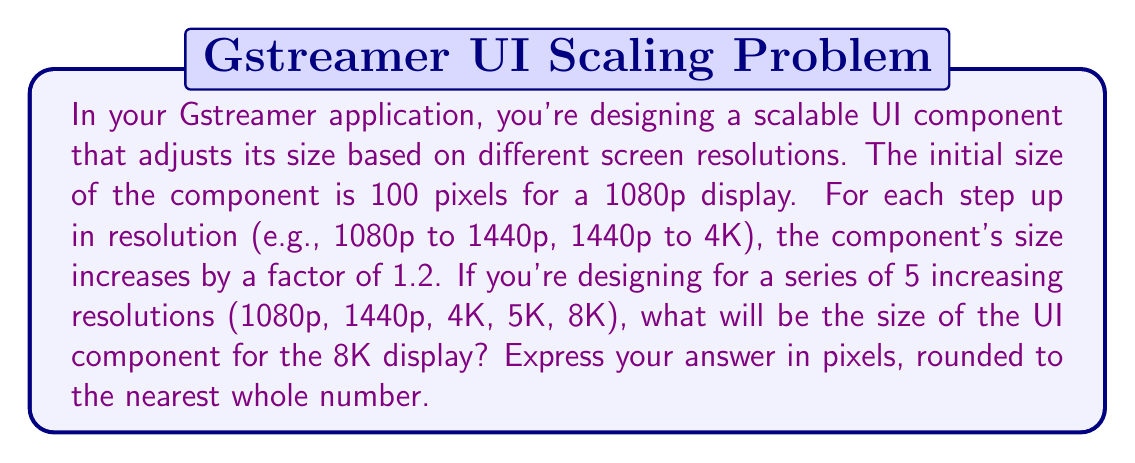Teach me how to tackle this problem. Let's approach this step-by-step:

1) We're dealing with a geometric sequence where each term is 1.2 times the previous term.
2) The initial term (a₁) is 100 pixels.
3) The common ratio (r) is 1.2.
4) We need to find the 5th term in this sequence (a₅).

The formula for the nth term of a geometric sequence is:

$$ a_n = a_1 \cdot r^{n-1} $$

Where:
- $a_n$ is the nth term
- $a_1$ is the first term
- $r$ is the common ratio
- $n$ is the position of the term

In our case:
$a_1 = 100$
$r = 1.2$
$n = 5$

Let's substitute these values:

$$ a_5 = 100 \cdot 1.2^{5-1} $$
$$ a_5 = 100 \cdot 1.2^4 $$
$$ a_5 = 100 \cdot 2.0736 $$
$$ a_5 = 207.36 $$

Rounding to the nearest whole number:
$$ a_5 \approx 207 \text{ pixels} $$
Answer: 207 pixels 